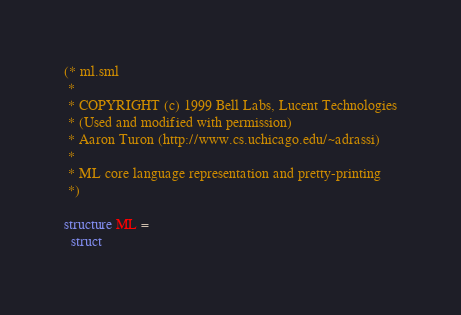Convert code to text. <code><loc_0><loc_0><loc_500><loc_500><_SML_>(* ml.sml
 *
 * COPYRIGHT (c) 1999 Bell Labs, Lucent Technologies
 * (Used and modified with permission)
 * Aaron Turon (http://www.cs.uchicago.edu/~adrassi)
 *
 * ML core language representation and pretty-printing
 *)

structure ML =
  struct
</code> 